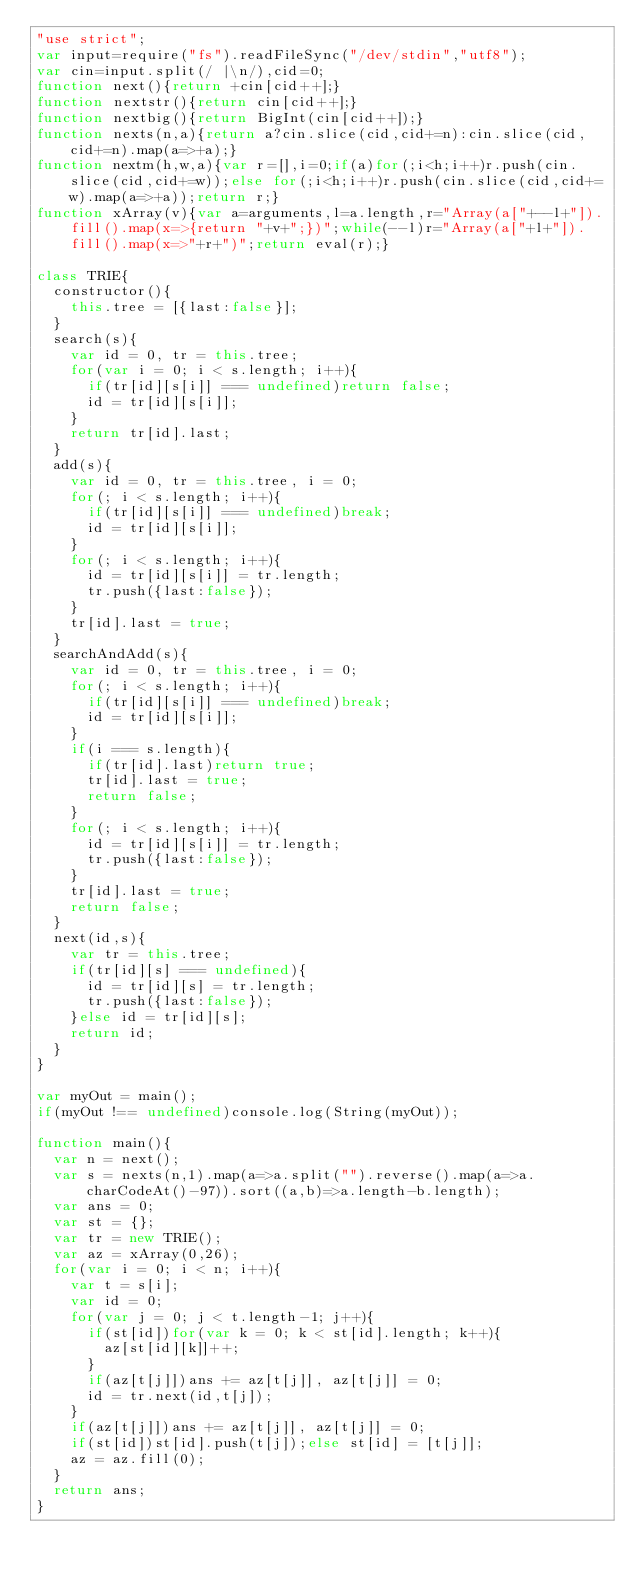Convert code to text. <code><loc_0><loc_0><loc_500><loc_500><_JavaScript_>"use strict";
var input=require("fs").readFileSync("/dev/stdin","utf8");
var cin=input.split(/ |\n/),cid=0;
function next(){return +cin[cid++];}
function nextstr(){return cin[cid++];}
function nextbig(){return BigInt(cin[cid++]);}
function nexts(n,a){return a?cin.slice(cid,cid+=n):cin.slice(cid,cid+=n).map(a=>+a);}
function nextm(h,w,a){var r=[],i=0;if(a)for(;i<h;i++)r.push(cin.slice(cid,cid+=w));else for(;i<h;i++)r.push(cin.slice(cid,cid+=w).map(a=>+a));return r;}
function xArray(v){var a=arguments,l=a.length,r="Array(a["+--l+"]).fill().map(x=>{return "+v+";})";while(--l)r="Array(a["+l+"]).fill().map(x=>"+r+")";return eval(r);}

class TRIE{
  constructor(){
    this.tree = [{last:false}];
  }
  search(s){
    var id = 0, tr = this.tree;
    for(var i = 0; i < s.length; i++){
      if(tr[id][s[i]] === undefined)return false;
      id = tr[id][s[i]];
    }
    return tr[id].last;
  }
  add(s){
    var id = 0, tr = this.tree, i = 0;
    for(; i < s.length; i++){
      if(tr[id][s[i]] === undefined)break;
      id = tr[id][s[i]];
    }
    for(; i < s.length; i++){
      id = tr[id][s[i]] = tr.length;
      tr.push({last:false});
    }
    tr[id].last = true;
  }
  searchAndAdd(s){
    var id = 0, tr = this.tree, i = 0;
    for(; i < s.length; i++){
      if(tr[id][s[i]] === undefined)break;
      id = tr[id][s[i]];
    }
    if(i === s.length){
      if(tr[id].last)return true;
      tr[id].last = true;
      return false;
    }
    for(; i < s.length; i++){
      id = tr[id][s[i]] = tr.length;
      tr.push({last:false});
    }
    tr[id].last = true;
    return false;
  }
  next(id,s){
    var tr = this.tree;
    if(tr[id][s] === undefined){
      id = tr[id][s] = tr.length;
      tr.push({last:false});
    }else id = tr[id][s];
    return id;
  }
}

var myOut = main();
if(myOut !== undefined)console.log(String(myOut));

function main(){
  var n = next();
  var s = nexts(n,1).map(a=>a.split("").reverse().map(a=>a.charCodeAt()-97)).sort((a,b)=>a.length-b.length);
  var ans = 0;
  var st = {};
  var tr = new TRIE();
  var az = xArray(0,26);
  for(var i = 0; i < n; i++){
    var t = s[i];
    var id = 0;
    for(var j = 0; j < t.length-1; j++){
      if(st[id])for(var k = 0; k < st[id].length; k++){
        az[st[id][k]]++;
      }
      if(az[t[j]])ans += az[t[j]], az[t[j]] = 0;
      id = tr.next(id,t[j]);
    }
    if(az[t[j]])ans += az[t[j]], az[t[j]] = 0;
    if(st[id])st[id].push(t[j]);else st[id] = [t[j]];
    az = az.fill(0);
  }
  return ans;
}</code> 